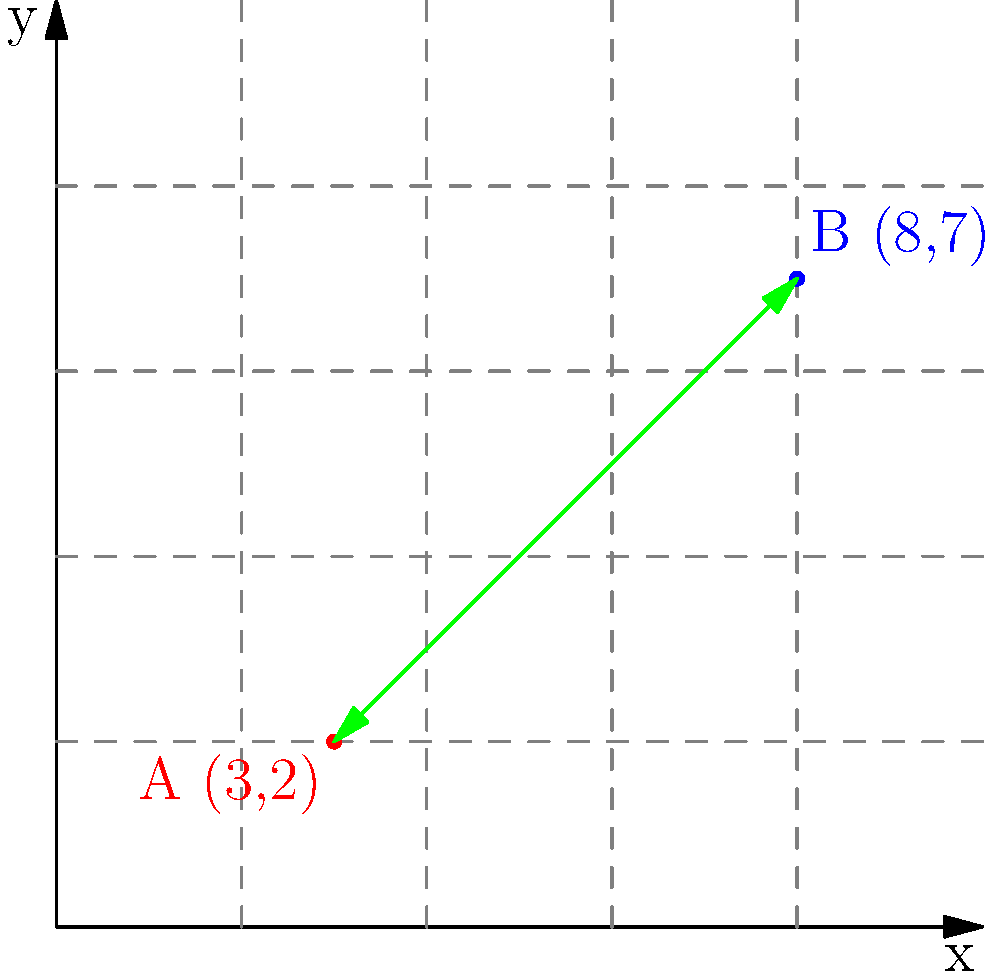In your virtual synthwave concert grid, two popular venues are represented by points A(3,2) and B(8,7). Calculate the distance between these two venues to determine the optimal path for attendees to travel between virtual listening parties. To find the distance between two points in a 2D plane, we use the distance formula derived from the Pythagorean theorem:

$$d = \sqrt{(x_2 - x_1)^2 + (y_2 - y_1)^2}$$

Where $(x_1, y_1)$ are the coordinates of the first point and $(x_2, y_2)$ are the coordinates of the second point.

Given:
Point A: $(x_1, y_1) = (3, 2)$
Point B: $(x_2, y_2) = (8, 7)$

Step 1: Substitute the values into the distance formula:
$$d = \sqrt{(8 - 3)^2 + (7 - 2)^2}$$

Step 2: Simplify the expressions inside the parentheses:
$$d = \sqrt{5^2 + 5^2}$$

Step 3: Calculate the squares:
$$d = \sqrt{25 + 25}$$

Step 4: Add the values under the square root:
$$d = \sqrt{50}$$

Step 5: Simplify the square root:
$$d = 5\sqrt{2}$$

Therefore, the distance between the two virtual concert venues is $5\sqrt{2}$ units on your grid.
Answer: $5\sqrt{2}$ units 